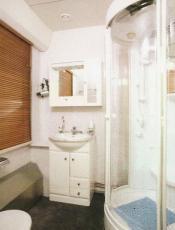What kind of window covering is shown here?
Short answer required. Blinds. Is there a mat in the shower?
Answer briefly. Yes. Is the image high or low resolution?
Give a very brief answer. Low. 